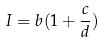Convert formula to latex. <formula><loc_0><loc_0><loc_500><loc_500>I = b ( 1 + \frac { c } { d } )</formula> 